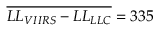Convert formula to latex. <formula><loc_0><loc_0><loc_500><loc_500>\overline { { L L _ { V I I R S } - L L _ { L L C } } } = 3 3 5</formula> 